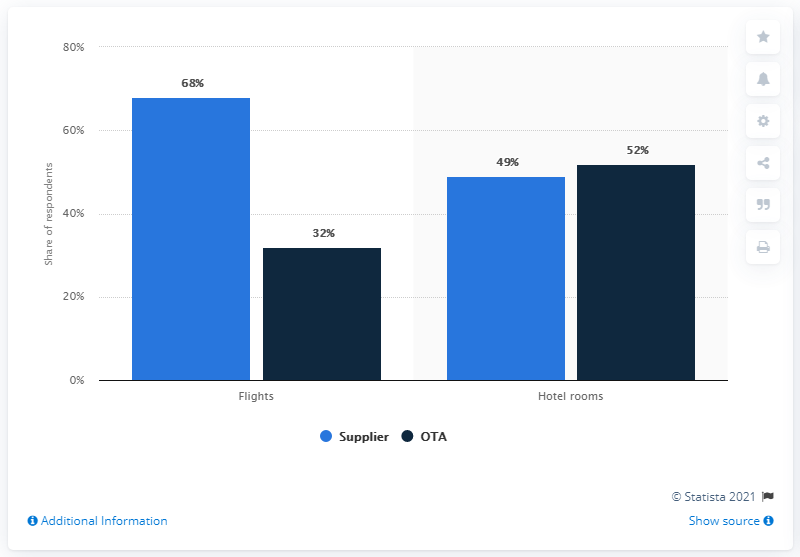Point out several critical features in this image. The difference between the suppliers of flights and hotel rooms is 19.. In flights, the supplier with the maximum share is the supplier. 